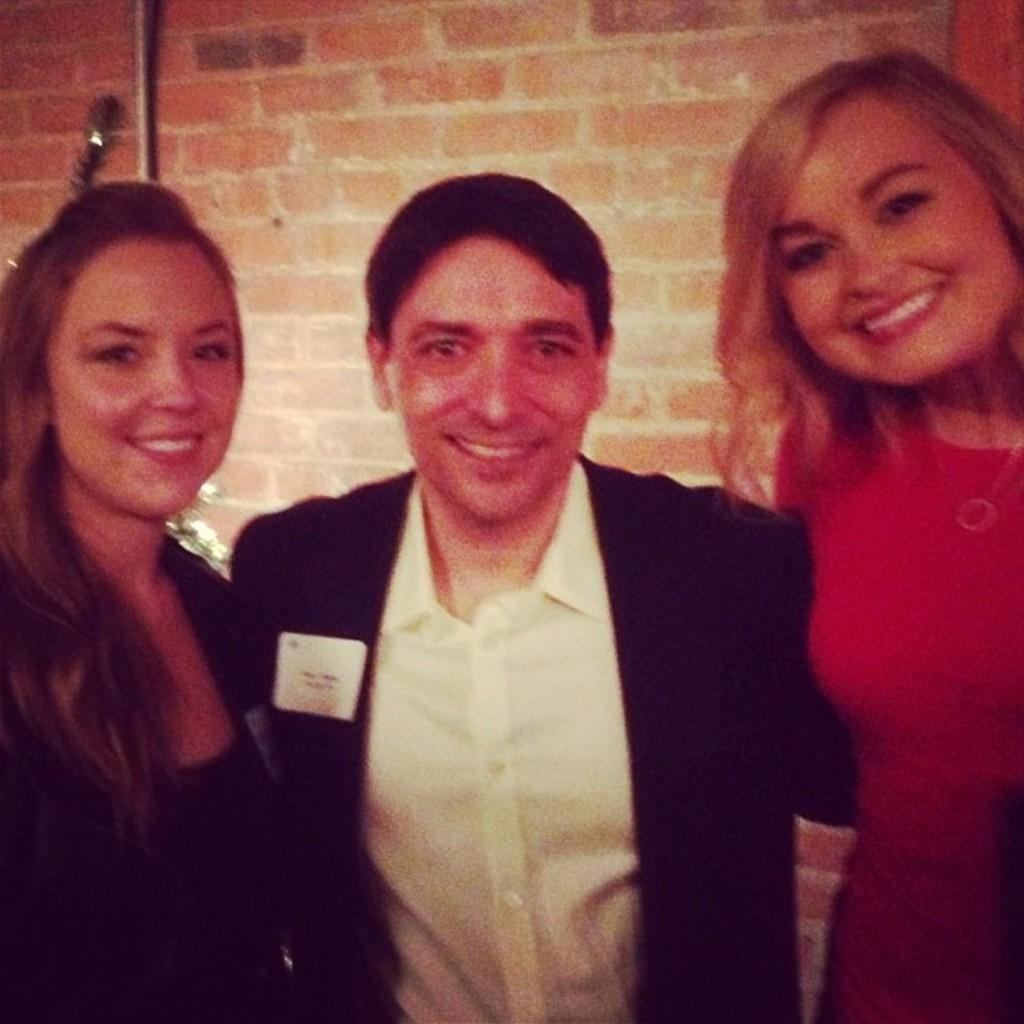How many people are in the image? There are three people in the image: two ladies and a guy. What is the guy wearing in the image? The guy is wearing a suit in the image. What can be seen in the background of the image? There is a brick wall in the background of the image. What type of straw is being used by the ladies in the image? There is no straw present in the image; the ladies are not holding or using any straws. 